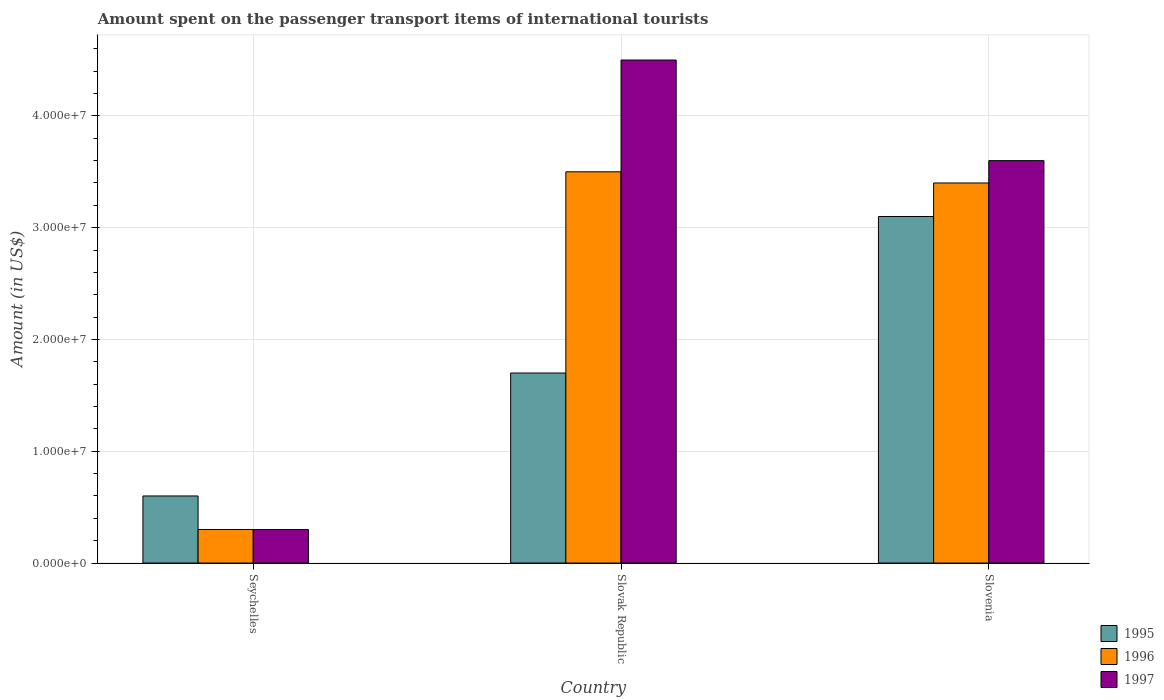How many different coloured bars are there?
Keep it short and to the point. 3. How many bars are there on the 3rd tick from the left?
Make the answer very short. 3. What is the label of the 2nd group of bars from the left?
Provide a succinct answer. Slovak Republic. Across all countries, what is the maximum amount spent on the passenger transport items of international tourists in 1996?
Offer a terse response. 3.50e+07. Across all countries, what is the minimum amount spent on the passenger transport items of international tourists in 1995?
Your response must be concise. 6.00e+06. In which country was the amount spent on the passenger transport items of international tourists in 1996 maximum?
Offer a very short reply. Slovak Republic. In which country was the amount spent on the passenger transport items of international tourists in 1995 minimum?
Offer a very short reply. Seychelles. What is the total amount spent on the passenger transport items of international tourists in 1996 in the graph?
Provide a succinct answer. 7.20e+07. What is the difference between the amount spent on the passenger transport items of international tourists in 1995 in Slovak Republic and that in Slovenia?
Your answer should be very brief. -1.40e+07. What is the difference between the amount spent on the passenger transport items of international tourists in 1997 in Slovak Republic and the amount spent on the passenger transport items of international tourists in 1996 in Seychelles?
Your answer should be very brief. 4.20e+07. What is the average amount spent on the passenger transport items of international tourists in 1995 per country?
Offer a very short reply. 1.80e+07. What is the ratio of the amount spent on the passenger transport items of international tourists in 1995 in Slovak Republic to that in Slovenia?
Your answer should be very brief. 0.55. Is the difference between the amount spent on the passenger transport items of international tourists in 1996 in Seychelles and Slovak Republic greater than the difference between the amount spent on the passenger transport items of international tourists in 1997 in Seychelles and Slovak Republic?
Give a very brief answer. Yes. What is the difference between the highest and the second highest amount spent on the passenger transport items of international tourists in 1996?
Provide a short and direct response. 1.00e+06. What is the difference between the highest and the lowest amount spent on the passenger transport items of international tourists in 1997?
Provide a succinct answer. 4.20e+07. Is the sum of the amount spent on the passenger transport items of international tourists in 1996 in Slovak Republic and Slovenia greater than the maximum amount spent on the passenger transport items of international tourists in 1995 across all countries?
Provide a short and direct response. Yes. What does the 2nd bar from the right in Seychelles represents?
Provide a short and direct response. 1996. Is it the case that in every country, the sum of the amount spent on the passenger transport items of international tourists in 1996 and amount spent on the passenger transport items of international tourists in 1997 is greater than the amount spent on the passenger transport items of international tourists in 1995?
Offer a terse response. No. How many bars are there?
Ensure brevity in your answer.  9. Are all the bars in the graph horizontal?
Offer a very short reply. No. What is the difference between two consecutive major ticks on the Y-axis?
Your answer should be very brief. 1.00e+07. Does the graph contain any zero values?
Offer a terse response. No. Does the graph contain grids?
Provide a short and direct response. Yes. How many legend labels are there?
Offer a very short reply. 3. What is the title of the graph?
Your response must be concise. Amount spent on the passenger transport items of international tourists. What is the label or title of the X-axis?
Keep it short and to the point. Country. What is the label or title of the Y-axis?
Your response must be concise. Amount (in US$). What is the Amount (in US$) of 1997 in Seychelles?
Your response must be concise. 3.00e+06. What is the Amount (in US$) in 1995 in Slovak Republic?
Your response must be concise. 1.70e+07. What is the Amount (in US$) of 1996 in Slovak Republic?
Give a very brief answer. 3.50e+07. What is the Amount (in US$) of 1997 in Slovak Republic?
Your answer should be compact. 4.50e+07. What is the Amount (in US$) of 1995 in Slovenia?
Your answer should be very brief. 3.10e+07. What is the Amount (in US$) of 1996 in Slovenia?
Offer a very short reply. 3.40e+07. What is the Amount (in US$) in 1997 in Slovenia?
Provide a short and direct response. 3.60e+07. Across all countries, what is the maximum Amount (in US$) in 1995?
Your answer should be very brief. 3.10e+07. Across all countries, what is the maximum Amount (in US$) in 1996?
Make the answer very short. 3.50e+07. Across all countries, what is the maximum Amount (in US$) in 1997?
Your response must be concise. 4.50e+07. Across all countries, what is the minimum Amount (in US$) of 1996?
Offer a very short reply. 3.00e+06. Across all countries, what is the minimum Amount (in US$) of 1997?
Provide a succinct answer. 3.00e+06. What is the total Amount (in US$) in 1995 in the graph?
Give a very brief answer. 5.40e+07. What is the total Amount (in US$) in 1996 in the graph?
Provide a short and direct response. 7.20e+07. What is the total Amount (in US$) in 1997 in the graph?
Keep it short and to the point. 8.40e+07. What is the difference between the Amount (in US$) of 1995 in Seychelles and that in Slovak Republic?
Your answer should be very brief. -1.10e+07. What is the difference between the Amount (in US$) in 1996 in Seychelles and that in Slovak Republic?
Your response must be concise. -3.20e+07. What is the difference between the Amount (in US$) of 1997 in Seychelles and that in Slovak Republic?
Offer a terse response. -4.20e+07. What is the difference between the Amount (in US$) of 1995 in Seychelles and that in Slovenia?
Provide a short and direct response. -2.50e+07. What is the difference between the Amount (in US$) of 1996 in Seychelles and that in Slovenia?
Make the answer very short. -3.10e+07. What is the difference between the Amount (in US$) of 1997 in Seychelles and that in Slovenia?
Ensure brevity in your answer.  -3.30e+07. What is the difference between the Amount (in US$) in 1995 in Slovak Republic and that in Slovenia?
Offer a terse response. -1.40e+07. What is the difference between the Amount (in US$) in 1997 in Slovak Republic and that in Slovenia?
Provide a short and direct response. 9.00e+06. What is the difference between the Amount (in US$) of 1995 in Seychelles and the Amount (in US$) of 1996 in Slovak Republic?
Offer a very short reply. -2.90e+07. What is the difference between the Amount (in US$) of 1995 in Seychelles and the Amount (in US$) of 1997 in Slovak Republic?
Provide a succinct answer. -3.90e+07. What is the difference between the Amount (in US$) in 1996 in Seychelles and the Amount (in US$) in 1997 in Slovak Republic?
Offer a terse response. -4.20e+07. What is the difference between the Amount (in US$) of 1995 in Seychelles and the Amount (in US$) of 1996 in Slovenia?
Keep it short and to the point. -2.80e+07. What is the difference between the Amount (in US$) in 1995 in Seychelles and the Amount (in US$) in 1997 in Slovenia?
Make the answer very short. -3.00e+07. What is the difference between the Amount (in US$) of 1996 in Seychelles and the Amount (in US$) of 1997 in Slovenia?
Give a very brief answer. -3.30e+07. What is the difference between the Amount (in US$) in 1995 in Slovak Republic and the Amount (in US$) in 1996 in Slovenia?
Offer a terse response. -1.70e+07. What is the difference between the Amount (in US$) of 1995 in Slovak Republic and the Amount (in US$) of 1997 in Slovenia?
Your response must be concise. -1.90e+07. What is the average Amount (in US$) in 1995 per country?
Make the answer very short. 1.80e+07. What is the average Amount (in US$) of 1996 per country?
Ensure brevity in your answer.  2.40e+07. What is the average Amount (in US$) in 1997 per country?
Give a very brief answer. 2.80e+07. What is the difference between the Amount (in US$) in 1995 and Amount (in US$) in 1996 in Seychelles?
Provide a succinct answer. 3.00e+06. What is the difference between the Amount (in US$) in 1995 and Amount (in US$) in 1997 in Seychelles?
Your answer should be compact. 3.00e+06. What is the difference between the Amount (in US$) of 1995 and Amount (in US$) of 1996 in Slovak Republic?
Your answer should be compact. -1.80e+07. What is the difference between the Amount (in US$) of 1995 and Amount (in US$) of 1997 in Slovak Republic?
Your response must be concise. -2.80e+07. What is the difference between the Amount (in US$) of 1996 and Amount (in US$) of 1997 in Slovak Republic?
Your answer should be compact. -1.00e+07. What is the difference between the Amount (in US$) in 1995 and Amount (in US$) in 1996 in Slovenia?
Provide a short and direct response. -3.00e+06. What is the difference between the Amount (in US$) of 1995 and Amount (in US$) of 1997 in Slovenia?
Your answer should be very brief. -5.00e+06. What is the difference between the Amount (in US$) of 1996 and Amount (in US$) of 1997 in Slovenia?
Ensure brevity in your answer.  -2.00e+06. What is the ratio of the Amount (in US$) of 1995 in Seychelles to that in Slovak Republic?
Your answer should be compact. 0.35. What is the ratio of the Amount (in US$) of 1996 in Seychelles to that in Slovak Republic?
Offer a terse response. 0.09. What is the ratio of the Amount (in US$) of 1997 in Seychelles to that in Slovak Republic?
Give a very brief answer. 0.07. What is the ratio of the Amount (in US$) of 1995 in Seychelles to that in Slovenia?
Keep it short and to the point. 0.19. What is the ratio of the Amount (in US$) in 1996 in Seychelles to that in Slovenia?
Your answer should be very brief. 0.09. What is the ratio of the Amount (in US$) in 1997 in Seychelles to that in Slovenia?
Provide a short and direct response. 0.08. What is the ratio of the Amount (in US$) in 1995 in Slovak Republic to that in Slovenia?
Provide a short and direct response. 0.55. What is the ratio of the Amount (in US$) in 1996 in Slovak Republic to that in Slovenia?
Keep it short and to the point. 1.03. What is the difference between the highest and the second highest Amount (in US$) of 1995?
Provide a succinct answer. 1.40e+07. What is the difference between the highest and the second highest Amount (in US$) in 1996?
Your answer should be very brief. 1.00e+06. What is the difference between the highest and the second highest Amount (in US$) of 1997?
Offer a terse response. 9.00e+06. What is the difference between the highest and the lowest Amount (in US$) in 1995?
Make the answer very short. 2.50e+07. What is the difference between the highest and the lowest Amount (in US$) in 1996?
Offer a terse response. 3.20e+07. What is the difference between the highest and the lowest Amount (in US$) of 1997?
Make the answer very short. 4.20e+07. 